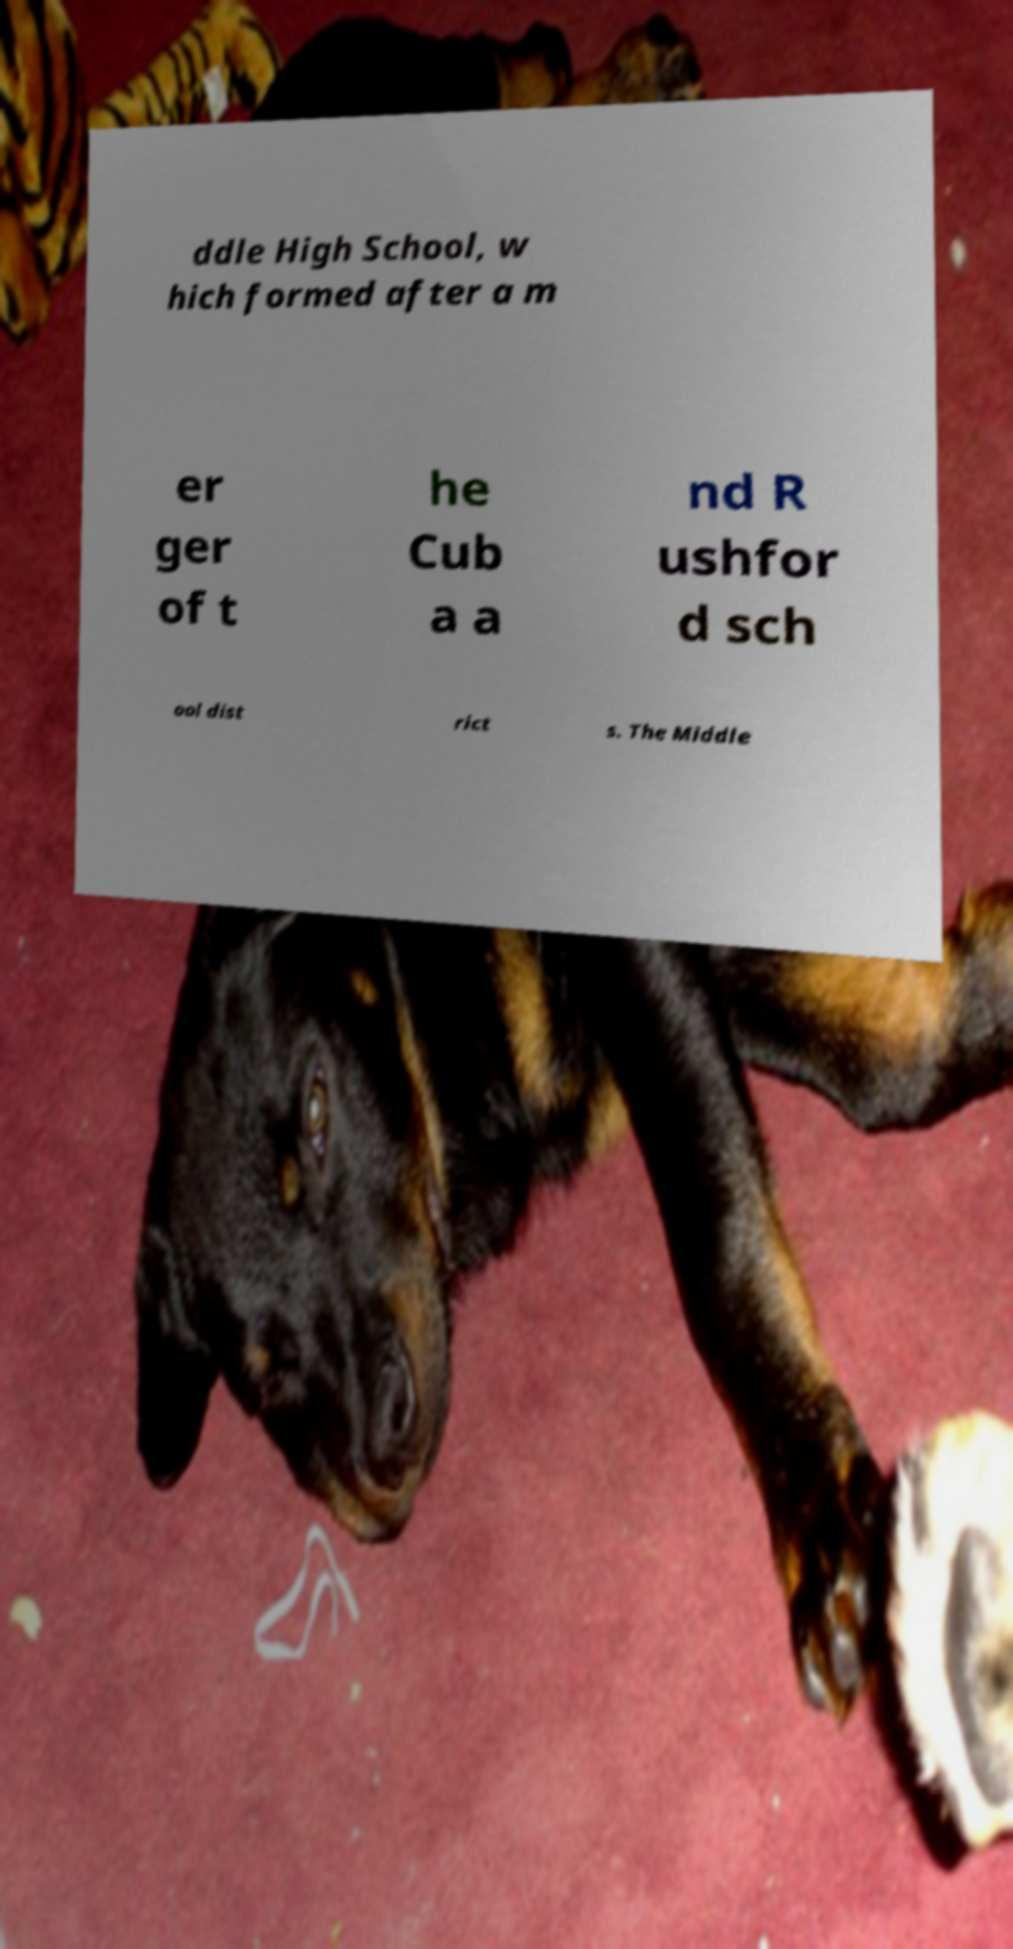Can you read and provide the text displayed in the image?This photo seems to have some interesting text. Can you extract and type it out for me? ddle High School, w hich formed after a m er ger of t he Cub a a nd R ushfor d sch ool dist rict s. The Middle 